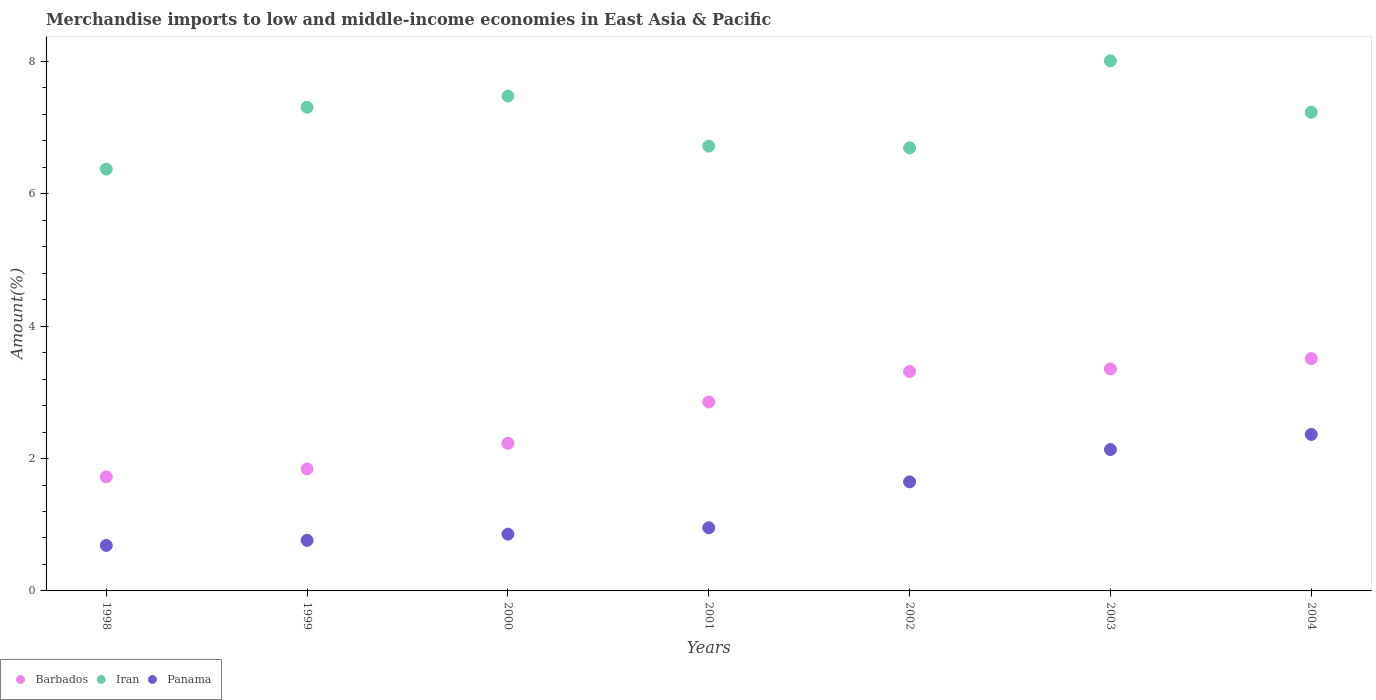Is the number of dotlines equal to the number of legend labels?
Give a very brief answer. Yes. What is the percentage of amount earned from merchandise imports in Iran in 2002?
Make the answer very short. 6.7. Across all years, what is the maximum percentage of amount earned from merchandise imports in Iran?
Make the answer very short. 8.01. Across all years, what is the minimum percentage of amount earned from merchandise imports in Panama?
Your answer should be compact. 0.69. What is the total percentage of amount earned from merchandise imports in Iran in the graph?
Make the answer very short. 49.82. What is the difference between the percentage of amount earned from merchandise imports in Panama in 2000 and that in 2001?
Your answer should be compact. -0.1. What is the difference between the percentage of amount earned from merchandise imports in Iran in 1998 and the percentage of amount earned from merchandise imports in Barbados in 1999?
Make the answer very short. 4.53. What is the average percentage of amount earned from merchandise imports in Iran per year?
Provide a succinct answer. 7.12. In the year 2001, what is the difference between the percentage of amount earned from merchandise imports in Barbados and percentage of amount earned from merchandise imports in Panama?
Offer a terse response. 1.9. In how many years, is the percentage of amount earned from merchandise imports in Panama greater than 4.8 %?
Ensure brevity in your answer.  0. What is the ratio of the percentage of amount earned from merchandise imports in Iran in 1998 to that in 1999?
Provide a succinct answer. 0.87. What is the difference between the highest and the second highest percentage of amount earned from merchandise imports in Barbados?
Your answer should be compact. 0.16. What is the difference between the highest and the lowest percentage of amount earned from merchandise imports in Panama?
Ensure brevity in your answer.  1.68. Is the sum of the percentage of amount earned from merchandise imports in Barbados in 2000 and 2003 greater than the maximum percentage of amount earned from merchandise imports in Iran across all years?
Your answer should be very brief. No. Is it the case that in every year, the sum of the percentage of amount earned from merchandise imports in Barbados and percentage of amount earned from merchandise imports in Iran  is greater than the percentage of amount earned from merchandise imports in Panama?
Offer a terse response. Yes. Does the percentage of amount earned from merchandise imports in Iran monotonically increase over the years?
Ensure brevity in your answer.  No. Is the percentage of amount earned from merchandise imports in Iran strictly greater than the percentage of amount earned from merchandise imports in Barbados over the years?
Keep it short and to the point. Yes. Is the percentage of amount earned from merchandise imports in Barbados strictly less than the percentage of amount earned from merchandise imports in Panama over the years?
Offer a very short reply. No. How many dotlines are there?
Give a very brief answer. 3. What is the difference between two consecutive major ticks on the Y-axis?
Provide a succinct answer. 2. Are the values on the major ticks of Y-axis written in scientific E-notation?
Give a very brief answer. No. Where does the legend appear in the graph?
Your response must be concise. Bottom left. How many legend labels are there?
Offer a very short reply. 3. What is the title of the graph?
Your response must be concise. Merchandise imports to low and middle-income economies in East Asia & Pacific. Does "Equatorial Guinea" appear as one of the legend labels in the graph?
Give a very brief answer. No. What is the label or title of the X-axis?
Make the answer very short. Years. What is the label or title of the Y-axis?
Your answer should be very brief. Amount(%). What is the Amount(%) of Barbados in 1998?
Keep it short and to the point. 1.72. What is the Amount(%) of Iran in 1998?
Keep it short and to the point. 6.37. What is the Amount(%) in Panama in 1998?
Your answer should be compact. 0.69. What is the Amount(%) in Barbados in 1999?
Offer a very short reply. 1.84. What is the Amount(%) in Iran in 1999?
Your response must be concise. 7.31. What is the Amount(%) of Panama in 1999?
Ensure brevity in your answer.  0.76. What is the Amount(%) of Barbados in 2000?
Provide a short and direct response. 2.23. What is the Amount(%) in Iran in 2000?
Your answer should be compact. 7.48. What is the Amount(%) in Panama in 2000?
Your response must be concise. 0.86. What is the Amount(%) of Barbados in 2001?
Your answer should be compact. 2.85. What is the Amount(%) in Iran in 2001?
Make the answer very short. 6.72. What is the Amount(%) of Panama in 2001?
Your answer should be compact. 0.95. What is the Amount(%) of Barbados in 2002?
Give a very brief answer. 3.32. What is the Amount(%) in Iran in 2002?
Ensure brevity in your answer.  6.7. What is the Amount(%) in Panama in 2002?
Ensure brevity in your answer.  1.65. What is the Amount(%) in Barbados in 2003?
Give a very brief answer. 3.36. What is the Amount(%) of Iran in 2003?
Keep it short and to the point. 8.01. What is the Amount(%) in Panama in 2003?
Offer a terse response. 2.14. What is the Amount(%) of Barbados in 2004?
Give a very brief answer. 3.51. What is the Amount(%) of Iran in 2004?
Make the answer very short. 7.23. What is the Amount(%) of Panama in 2004?
Keep it short and to the point. 2.37. Across all years, what is the maximum Amount(%) of Barbados?
Keep it short and to the point. 3.51. Across all years, what is the maximum Amount(%) in Iran?
Give a very brief answer. 8.01. Across all years, what is the maximum Amount(%) of Panama?
Ensure brevity in your answer.  2.37. Across all years, what is the minimum Amount(%) in Barbados?
Provide a succinct answer. 1.72. Across all years, what is the minimum Amount(%) of Iran?
Provide a succinct answer. 6.37. Across all years, what is the minimum Amount(%) in Panama?
Offer a very short reply. 0.69. What is the total Amount(%) in Barbados in the graph?
Offer a very short reply. 18.84. What is the total Amount(%) in Iran in the graph?
Ensure brevity in your answer.  49.82. What is the total Amount(%) of Panama in the graph?
Give a very brief answer. 9.41. What is the difference between the Amount(%) in Barbados in 1998 and that in 1999?
Keep it short and to the point. -0.12. What is the difference between the Amount(%) of Iran in 1998 and that in 1999?
Provide a succinct answer. -0.93. What is the difference between the Amount(%) in Panama in 1998 and that in 1999?
Make the answer very short. -0.08. What is the difference between the Amount(%) of Barbados in 1998 and that in 2000?
Ensure brevity in your answer.  -0.51. What is the difference between the Amount(%) in Iran in 1998 and that in 2000?
Make the answer very short. -1.1. What is the difference between the Amount(%) of Panama in 1998 and that in 2000?
Ensure brevity in your answer.  -0.17. What is the difference between the Amount(%) in Barbados in 1998 and that in 2001?
Your response must be concise. -1.13. What is the difference between the Amount(%) of Iran in 1998 and that in 2001?
Your answer should be compact. -0.35. What is the difference between the Amount(%) of Panama in 1998 and that in 2001?
Your answer should be very brief. -0.27. What is the difference between the Amount(%) in Barbados in 1998 and that in 2002?
Provide a succinct answer. -1.59. What is the difference between the Amount(%) of Iran in 1998 and that in 2002?
Provide a succinct answer. -0.32. What is the difference between the Amount(%) of Panama in 1998 and that in 2002?
Offer a very short reply. -0.96. What is the difference between the Amount(%) of Barbados in 1998 and that in 2003?
Keep it short and to the point. -1.63. What is the difference between the Amount(%) of Iran in 1998 and that in 2003?
Ensure brevity in your answer.  -1.64. What is the difference between the Amount(%) of Panama in 1998 and that in 2003?
Provide a succinct answer. -1.45. What is the difference between the Amount(%) in Barbados in 1998 and that in 2004?
Give a very brief answer. -1.79. What is the difference between the Amount(%) of Iran in 1998 and that in 2004?
Your answer should be very brief. -0.86. What is the difference between the Amount(%) of Panama in 1998 and that in 2004?
Offer a terse response. -1.68. What is the difference between the Amount(%) of Barbados in 1999 and that in 2000?
Make the answer very short. -0.39. What is the difference between the Amount(%) in Iran in 1999 and that in 2000?
Your answer should be compact. -0.17. What is the difference between the Amount(%) in Panama in 1999 and that in 2000?
Make the answer very short. -0.09. What is the difference between the Amount(%) of Barbados in 1999 and that in 2001?
Make the answer very short. -1.01. What is the difference between the Amount(%) in Iran in 1999 and that in 2001?
Your response must be concise. 0.59. What is the difference between the Amount(%) of Panama in 1999 and that in 2001?
Provide a short and direct response. -0.19. What is the difference between the Amount(%) of Barbados in 1999 and that in 2002?
Ensure brevity in your answer.  -1.47. What is the difference between the Amount(%) in Iran in 1999 and that in 2002?
Your answer should be compact. 0.61. What is the difference between the Amount(%) in Panama in 1999 and that in 2002?
Make the answer very short. -0.88. What is the difference between the Amount(%) of Barbados in 1999 and that in 2003?
Provide a succinct answer. -1.51. What is the difference between the Amount(%) of Iran in 1999 and that in 2003?
Your answer should be compact. -0.7. What is the difference between the Amount(%) in Panama in 1999 and that in 2003?
Keep it short and to the point. -1.37. What is the difference between the Amount(%) of Barbados in 1999 and that in 2004?
Offer a very short reply. -1.67. What is the difference between the Amount(%) in Iran in 1999 and that in 2004?
Provide a short and direct response. 0.08. What is the difference between the Amount(%) in Panama in 1999 and that in 2004?
Provide a succinct answer. -1.6. What is the difference between the Amount(%) in Barbados in 2000 and that in 2001?
Provide a short and direct response. -0.62. What is the difference between the Amount(%) in Iran in 2000 and that in 2001?
Offer a very short reply. 0.76. What is the difference between the Amount(%) of Panama in 2000 and that in 2001?
Provide a short and direct response. -0.1. What is the difference between the Amount(%) in Barbados in 2000 and that in 2002?
Your answer should be compact. -1.08. What is the difference between the Amount(%) in Iran in 2000 and that in 2002?
Make the answer very short. 0.78. What is the difference between the Amount(%) of Panama in 2000 and that in 2002?
Provide a short and direct response. -0.79. What is the difference between the Amount(%) in Barbados in 2000 and that in 2003?
Offer a terse response. -1.12. What is the difference between the Amount(%) of Iran in 2000 and that in 2003?
Your answer should be compact. -0.53. What is the difference between the Amount(%) of Panama in 2000 and that in 2003?
Provide a succinct answer. -1.28. What is the difference between the Amount(%) of Barbados in 2000 and that in 2004?
Provide a short and direct response. -1.28. What is the difference between the Amount(%) of Iran in 2000 and that in 2004?
Offer a very short reply. 0.24. What is the difference between the Amount(%) of Panama in 2000 and that in 2004?
Ensure brevity in your answer.  -1.51. What is the difference between the Amount(%) in Barbados in 2001 and that in 2002?
Make the answer very short. -0.46. What is the difference between the Amount(%) in Iran in 2001 and that in 2002?
Offer a very short reply. 0.03. What is the difference between the Amount(%) of Panama in 2001 and that in 2002?
Provide a short and direct response. -0.69. What is the difference between the Amount(%) of Barbados in 2001 and that in 2003?
Provide a short and direct response. -0.5. What is the difference between the Amount(%) in Iran in 2001 and that in 2003?
Your response must be concise. -1.29. What is the difference between the Amount(%) of Panama in 2001 and that in 2003?
Ensure brevity in your answer.  -1.18. What is the difference between the Amount(%) in Barbados in 2001 and that in 2004?
Offer a very short reply. -0.66. What is the difference between the Amount(%) in Iran in 2001 and that in 2004?
Keep it short and to the point. -0.51. What is the difference between the Amount(%) of Panama in 2001 and that in 2004?
Keep it short and to the point. -1.41. What is the difference between the Amount(%) in Barbados in 2002 and that in 2003?
Provide a short and direct response. -0.04. What is the difference between the Amount(%) in Iran in 2002 and that in 2003?
Keep it short and to the point. -1.32. What is the difference between the Amount(%) in Panama in 2002 and that in 2003?
Make the answer very short. -0.49. What is the difference between the Amount(%) in Barbados in 2002 and that in 2004?
Provide a short and direct response. -0.2. What is the difference between the Amount(%) in Iran in 2002 and that in 2004?
Your answer should be compact. -0.54. What is the difference between the Amount(%) of Panama in 2002 and that in 2004?
Give a very brief answer. -0.72. What is the difference between the Amount(%) in Barbados in 2003 and that in 2004?
Offer a very short reply. -0.16. What is the difference between the Amount(%) in Iran in 2003 and that in 2004?
Offer a terse response. 0.78. What is the difference between the Amount(%) in Panama in 2003 and that in 2004?
Give a very brief answer. -0.23. What is the difference between the Amount(%) of Barbados in 1998 and the Amount(%) of Iran in 1999?
Offer a terse response. -5.58. What is the difference between the Amount(%) of Barbados in 1998 and the Amount(%) of Panama in 1999?
Provide a short and direct response. 0.96. What is the difference between the Amount(%) of Iran in 1998 and the Amount(%) of Panama in 1999?
Provide a short and direct response. 5.61. What is the difference between the Amount(%) in Barbados in 1998 and the Amount(%) in Iran in 2000?
Provide a succinct answer. -5.75. What is the difference between the Amount(%) of Barbados in 1998 and the Amount(%) of Panama in 2000?
Your answer should be very brief. 0.87. What is the difference between the Amount(%) in Iran in 1998 and the Amount(%) in Panama in 2000?
Offer a very short reply. 5.52. What is the difference between the Amount(%) in Barbados in 1998 and the Amount(%) in Iran in 2001?
Offer a terse response. -5. What is the difference between the Amount(%) of Barbados in 1998 and the Amount(%) of Panama in 2001?
Keep it short and to the point. 0.77. What is the difference between the Amount(%) in Iran in 1998 and the Amount(%) in Panama in 2001?
Offer a very short reply. 5.42. What is the difference between the Amount(%) of Barbados in 1998 and the Amount(%) of Iran in 2002?
Provide a short and direct response. -4.97. What is the difference between the Amount(%) in Barbados in 1998 and the Amount(%) in Panama in 2002?
Your answer should be very brief. 0.08. What is the difference between the Amount(%) of Iran in 1998 and the Amount(%) of Panama in 2002?
Your answer should be very brief. 4.73. What is the difference between the Amount(%) in Barbados in 1998 and the Amount(%) in Iran in 2003?
Ensure brevity in your answer.  -6.29. What is the difference between the Amount(%) of Barbados in 1998 and the Amount(%) of Panama in 2003?
Your answer should be compact. -0.41. What is the difference between the Amount(%) of Iran in 1998 and the Amount(%) of Panama in 2003?
Your answer should be very brief. 4.24. What is the difference between the Amount(%) in Barbados in 1998 and the Amount(%) in Iran in 2004?
Provide a succinct answer. -5.51. What is the difference between the Amount(%) in Barbados in 1998 and the Amount(%) in Panama in 2004?
Offer a very short reply. -0.64. What is the difference between the Amount(%) of Iran in 1998 and the Amount(%) of Panama in 2004?
Your answer should be very brief. 4.01. What is the difference between the Amount(%) in Barbados in 1999 and the Amount(%) in Iran in 2000?
Your answer should be compact. -5.63. What is the difference between the Amount(%) in Barbados in 1999 and the Amount(%) in Panama in 2000?
Keep it short and to the point. 0.99. What is the difference between the Amount(%) of Iran in 1999 and the Amount(%) of Panama in 2000?
Make the answer very short. 6.45. What is the difference between the Amount(%) of Barbados in 1999 and the Amount(%) of Iran in 2001?
Ensure brevity in your answer.  -4.88. What is the difference between the Amount(%) of Barbados in 1999 and the Amount(%) of Panama in 2001?
Provide a short and direct response. 0.89. What is the difference between the Amount(%) in Iran in 1999 and the Amount(%) in Panama in 2001?
Your response must be concise. 6.35. What is the difference between the Amount(%) in Barbados in 1999 and the Amount(%) in Iran in 2002?
Make the answer very short. -4.85. What is the difference between the Amount(%) of Barbados in 1999 and the Amount(%) of Panama in 2002?
Keep it short and to the point. 0.2. What is the difference between the Amount(%) of Iran in 1999 and the Amount(%) of Panama in 2002?
Give a very brief answer. 5.66. What is the difference between the Amount(%) in Barbados in 1999 and the Amount(%) in Iran in 2003?
Ensure brevity in your answer.  -6.17. What is the difference between the Amount(%) in Barbados in 1999 and the Amount(%) in Panama in 2003?
Ensure brevity in your answer.  -0.29. What is the difference between the Amount(%) of Iran in 1999 and the Amount(%) of Panama in 2003?
Give a very brief answer. 5.17. What is the difference between the Amount(%) of Barbados in 1999 and the Amount(%) of Iran in 2004?
Ensure brevity in your answer.  -5.39. What is the difference between the Amount(%) in Barbados in 1999 and the Amount(%) in Panama in 2004?
Your answer should be compact. -0.52. What is the difference between the Amount(%) in Iran in 1999 and the Amount(%) in Panama in 2004?
Your response must be concise. 4.94. What is the difference between the Amount(%) of Barbados in 2000 and the Amount(%) of Iran in 2001?
Give a very brief answer. -4.49. What is the difference between the Amount(%) of Barbados in 2000 and the Amount(%) of Panama in 2001?
Your response must be concise. 1.28. What is the difference between the Amount(%) in Iran in 2000 and the Amount(%) in Panama in 2001?
Provide a short and direct response. 6.52. What is the difference between the Amount(%) in Barbados in 2000 and the Amount(%) in Iran in 2002?
Offer a terse response. -4.46. What is the difference between the Amount(%) in Barbados in 2000 and the Amount(%) in Panama in 2002?
Offer a terse response. 0.58. What is the difference between the Amount(%) in Iran in 2000 and the Amount(%) in Panama in 2002?
Provide a succinct answer. 5.83. What is the difference between the Amount(%) of Barbados in 2000 and the Amount(%) of Iran in 2003?
Your response must be concise. -5.78. What is the difference between the Amount(%) of Barbados in 2000 and the Amount(%) of Panama in 2003?
Keep it short and to the point. 0.1. What is the difference between the Amount(%) in Iran in 2000 and the Amount(%) in Panama in 2003?
Give a very brief answer. 5.34. What is the difference between the Amount(%) in Barbados in 2000 and the Amount(%) in Iran in 2004?
Give a very brief answer. -5. What is the difference between the Amount(%) in Barbados in 2000 and the Amount(%) in Panama in 2004?
Offer a terse response. -0.13. What is the difference between the Amount(%) of Iran in 2000 and the Amount(%) of Panama in 2004?
Offer a very short reply. 5.11. What is the difference between the Amount(%) in Barbados in 2001 and the Amount(%) in Iran in 2002?
Offer a terse response. -3.84. What is the difference between the Amount(%) in Barbados in 2001 and the Amount(%) in Panama in 2002?
Offer a very short reply. 1.21. What is the difference between the Amount(%) in Iran in 2001 and the Amount(%) in Panama in 2002?
Ensure brevity in your answer.  5.07. What is the difference between the Amount(%) in Barbados in 2001 and the Amount(%) in Iran in 2003?
Provide a succinct answer. -5.16. What is the difference between the Amount(%) of Barbados in 2001 and the Amount(%) of Panama in 2003?
Make the answer very short. 0.72. What is the difference between the Amount(%) in Iran in 2001 and the Amount(%) in Panama in 2003?
Provide a succinct answer. 4.59. What is the difference between the Amount(%) in Barbados in 2001 and the Amount(%) in Iran in 2004?
Keep it short and to the point. -4.38. What is the difference between the Amount(%) in Barbados in 2001 and the Amount(%) in Panama in 2004?
Offer a very short reply. 0.49. What is the difference between the Amount(%) of Iran in 2001 and the Amount(%) of Panama in 2004?
Make the answer very short. 4.36. What is the difference between the Amount(%) in Barbados in 2002 and the Amount(%) in Iran in 2003?
Offer a terse response. -4.69. What is the difference between the Amount(%) in Barbados in 2002 and the Amount(%) in Panama in 2003?
Offer a terse response. 1.18. What is the difference between the Amount(%) in Iran in 2002 and the Amount(%) in Panama in 2003?
Ensure brevity in your answer.  4.56. What is the difference between the Amount(%) of Barbados in 2002 and the Amount(%) of Iran in 2004?
Offer a very short reply. -3.92. What is the difference between the Amount(%) in Barbados in 2002 and the Amount(%) in Panama in 2004?
Provide a succinct answer. 0.95. What is the difference between the Amount(%) of Iran in 2002 and the Amount(%) of Panama in 2004?
Provide a short and direct response. 4.33. What is the difference between the Amount(%) in Barbados in 2003 and the Amount(%) in Iran in 2004?
Your answer should be very brief. -3.88. What is the difference between the Amount(%) of Iran in 2003 and the Amount(%) of Panama in 2004?
Your response must be concise. 5.65. What is the average Amount(%) in Barbados per year?
Your answer should be very brief. 2.69. What is the average Amount(%) of Iran per year?
Keep it short and to the point. 7.12. What is the average Amount(%) in Panama per year?
Ensure brevity in your answer.  1.34. In the year 1998, what is the difference between the Amount(%) of Barbados and Amount(%) of Iran?
Offer a very short reply. -4.65. In the year 1998, what is the difference between the Amount(%) in Barbados and Amount(%) in Panama?
Make the answer very short. 1.04. In the year 1998, what is the difference between the Amount(%) of Iran and Amount(%) of Panama?
Provide a succinct answer. 5.69. In the year 1999, what is the difference between the Amount(%) of Barbados and Amount(%) of Iran?
Ensure brevity in your answer.  -5.46. In the year 1999, what is the difference between the Amount(%) of Barbados and Amount(%) of Panama?
Your answer should be compact. 1.08. In the year 1999, what is the difference between the Amount(%) in Iran and Amount(%) in Panama?
Your answer should be very brief. 6.54. In the year 2000, what is the difference between the Amount(%) of Barbados and Amount(%) of Iran?
Keep it short and to the point. -5.25. In the year 2000, what is the difference between the Amount(%) of Barbados and Amount(%) of Panama?
Offer a very short reply. 1.37. In the year 2000, what is the difference between the Amount(%) in Iran and Amount(%) in Panama?
Make the answer very short. 6.62. In the year 2001, what is the difference between the Amount(%) of Barbados and Amount(%) of Iran?
Provide a short and direct response. -3.87. In the year 2001, what is the difference between the Amount(%) in Barbados and Amount(%) in Panama?
Your answer should be compact. 1.9. In the year 2001, what is the difference between the Amount(%) of Iran and Amount(%) of Panama?
Your answer should be very brief. 5.77. In the year 2002, what is the difference between the Amount(%) of Barbados and Amount(%) of Iran?
Provide a short and direct response. -3.38. In the year 2002, what is the difference between the Amount(%) in Barbados and Amount(%) in Panama?
Your answer should be very brief. 1.67. In the year 2002, what is the difference between the Amount(%) of Iran and Amount(%) of Panama?
Keep it short and to the point. 5.05. In the year 2003, what is the difference between the Amount(%) in Barbados and Amount(%) in Iran?
Offer a very short reply. -4.66. In the year 2003, what is the difference between the Amount(%) in Barbados and Amount(%) in Panama?
Keep it short and to the point. 1.22. In the year 2003, what is the difference between the Amount(%) of Iran and Amount(%) of Panama?
Keep it short and to the point. 5.88. In the year 2004, what is the difference between the Amount(%) in Barbados and Amount(%) in Iran?
Your answer should be compact. -3.72. In the year 2004, what is the difference between the Amount(%) in Barbados and Amount(%) in Panama?
Offer a terse response. 1.15. In the year 2004, what is the difference between the Amount(%) of Iran and Amount(%) of Panama?
Your answer should be compact. 4.87. What is the ratio of the Amount(%) in Barbados in 1998 to that in 1999?
Make the answer very short. 0.93. What is the ratio of the Amount(%) of Iran in 1998 to that in 1999?
Your answer should be compact. 0.87. What is the ratio of the Amount(%) of Panama in 1998 to that in 1999?
Your response must be concise. 0.9. What is the ratio of the Amount(%) in Barbados in 1998 to that in 2000?
Your response must be concise. 0.77. What is the ratio of the Amount(%) of Iran in 1998 to that in 2000?
Keep it short and to the point. 0.85. What is the ratio of the Amount(%) in Panama in 1998 to that in 2000?
Your answer should be very brief. 0.8. What is the ratio of the Amount(%) of Barbados in 1998 to that in 2001?
Your answer should be very brief. 0.6. What is the ratio of the Amount(%) in Iran in 1998 to that in 2001?
Your answer should be compact. 0.95. What is the ratio of the Amount(%) in Panama in 1998 to that in 2001?
Provide a succinct answer. 0.72. What is the ratio of the Amount(%) in Barbados in 1998 to that in 2002?
Make the answer very short. 0.52. What is the ratio of the Amount(%) of Panama in 1998 to that in 2002?
Offer a very short reply. 0.42. What is the ratio of the Amount(%) in Barbados in 1998 to that in 2003?
Provide a succinct answer. 0.51. What is the ratio of the Amount(%) of Iran in 1998 to that in 2003?
Your response must be concise. 0.8. What is the ratio of the Amount(%) in Panama in 1998 to that in 2003?
Make the answer very short. 0.32. What is the ratio of the Amount(%) of Barbados in 1998 to that in 2004?
Your response must be concise. 0.49. What is the ratio of the Amount(%) in Iran in 1998 to that in 2004?
Offer a terse response. 0.88. What is the ratio of the Amount(%) in Panama in 1998 to that in 2004?
Your answer should be very brief. 0.29. What is the ratio of the Amount(%) of Barbados in 1999 to that in 2000?
Your answer should be compact. 0.83. What is the ratio of the Amount(%) of Iran in 1999 to that in 2000?
Make the answer very short. 0.98. What is the ratio of the Amount(%) of Panama in 1999 to that in 2000?
Offer a terse response. 0.89. What is the ratio of the Amount(%) of Barbados in 1999 to that in 2001?
Your answer should be very brief. 0.65. What is the ratio of the Amount(%) in Iran in 1999 to that in 2001?
Provide a short and direct response. 1.09. What is the ratio of the Amount(%) in Panama in 1999 to that in 2001?
Keep it short and to the point. 0.8. What is the ratio of the Amount(%) of Barbados in 1999 to that in 2002?
Ensure brevity in your answer.  0.56. What is the ratio of the Amount(%) in Iran in 1999 to that in 2002?
Offer a very short reply. 1.09. What is the ratio of the Amount(%) in Panama in 1999 to that in 2002?
Ensure brevity in your answer.  0.46. What is the ratio of the Amount(%) in Barbados in 1999 to that in 2003?
Ensure brevity in your answer.  0.55. What is the ratio of the Amount(%) of Iran in 1999 to that in 2003?
Give a very brief answer. 0.91. What is the ratio of the Amount(%) of Panama in 1999 to that in 2003?
Provide a succinct answer. 0.36. What is the ratio of the Amount(%) in Barbados in 1999 to that in 2004?
Your answer should be very brief. 0.53. What is the ratio of the Amount(%) in Iran in 1999 to that in 2004?
Offer a very short reply. 1.01. What is the ratio of the Amount(%) of Panama in 1999 to that in 2004?
Your response must be concise. 0.32. What is the ratio of the Amount(%) in Barbados in 2000 to that in 2001?
Your answer should be compact. 0.78. What is the ratio of the Amount(%) of Iran in 2000 to that in 2001?
Offer a terse response. 1.11. What is the ratio of the Amount(%) in Panama in 2000 to that in 2001?
Offer a terse response. 0.9. What is the ratio of the Amount(%) in Barbados in 2000 to that in 2002?
Provide a succinct answer. 0.67. What is the ratio of the Amount(%) of Iran in 2000 to that in 2002?
Give a very brief answer. 1.12. What is the ratio of the Amount(%) of Panama in 2000 to that in 2002?
Your response must be concise. 0.52. What is the ratio of the Amount(%) of Barbados in 2000 to that in 2003?
Your response must be concise. 0.67. What is the ratio of the Amount(%) of Iran in 2000 to that in 2003?
Your answer should be compact. 0.93. What is the ratio of the Amount(%) in Panama in 2000 to that in 2003?
Give a very brief answer. 0.4. What is the ratio of the Amount(%) in Barbados in 2000 to that in 2004?
Your answer should be very brief. 0.64. What is the ratio of the Amount(%) in Iran in 2000 to that in 2004?
Ensure brevity in your answer.  1.03. What is the ratio of the Amount(%) in Panama in 2000 to that in 2004?
Make the answer very short. 0.36. What is the ratio of the Amount(%) of Barbados in 2001 to that in 2002?
Ensure brevity in your answer.  0.86. What is the ratio of the Amount(%) in Iran in 2001 to that in 2002?
Your answer should be compact. 1. What is the ratio of the Amount(%) in Panama in 2001 to that in 2002?
Provide a short and direct response. 0.58. What is the ratio of the Amount(%) in Barbados in 2001 to that in 2003?
Your answer should be compact. 0.85. What is the ratio of the Amount(%) of Iran in 2001 to that in 2003?
Keep it short and to the point. 0.84. What is the ratio of the Amount(%) of Panama in 2001 to that in 2003?
Give a very brief answer. 0.45. What is the ratio of the Amount(%) in Barbados in 2001 to that in 2004?
Provide a short and direct response. 0.81. What is the ratio of the Amount(%) in Iran in 2001 to that in 2004?
Offer a terse response. 0.93. What is the ratio of the Amount(%) in Panama in 2001 to that in 2004?
Offer a very short reply. 0.4. What is the ratio of the Amount(%) in Barbados in 2002 to that in 2003?
Your response must be concise. 0.99. What is the ratio of the Amount(%) of Iran in 2002 to that in 2003?
Your response must be concise. 0.84. What is the ratio of the Amount(%) of Panama in 2002 to that in 2003?
Provide a succinct answer. 0.77. What is the ratio of the Amount(%) in Barbados in 2002 to that in 2004?
Offer a terse response. 0.94. What is the ratio of the Amount(%) of Iran in 2002 to that in 2004?
Make the answer very short. 0.93. What is the ratio of the Amount(%) of Panama in 2002 to that in 2004?
Your response must be concise. 0.7. What is the ratio of the Amount(%) in Barbados in 2003 to that in 2004?
Provide a succinct answer. 0.96. What is the ratio of the Amount(%) in Iran in 2003 to that in 2004?
Your answer should be compact. 1.11. What is the ratio of the Amount(%) in Panama in 2003 to that in 2004?
Offer a terse response. 0.9. What is the difference between the highest and the second highest Amount(%) in Barbados?
Provide a short and direct response. 0.16. What is the difference between the highest and the second highest Amount(%) in Iran?
Your answer should be compact. 0.53. What is the difference between the highest and the second highest Amount(%) of Panama?
Make the answer very short. 0.23. What is the difference between the highest and the lowest Amount(%) in Barbados?
Your response must be concise. 1.79. What is the difference between the highest and the lowest Amount(%) of Iran?
Ensure brevity in your answer.  1.64. What is the difference between the highest and the lowest Amount(%) in Panama?
Your response must be concise. 1.68. 